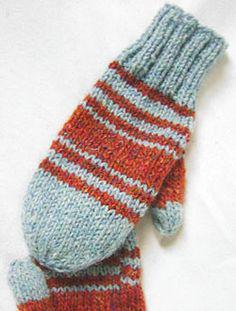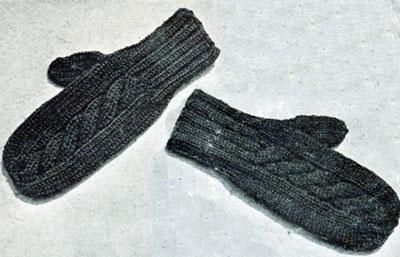The first image is the image on the left, the second image is the image on the right. Examine the images to the left and right. Is the description "The mittens in the left image are on a pair of human hands." accurate? Answer yes or no. No. The first image is the image on the left, the second image is the image on the right. For the images shown, is this caption "One pair of mittens features at least two or more colors in a patterned design." true? Answer yes or no. Yes. 